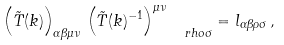<formula> <loc_0><loc_0><loc_500><loc_500>\left ( \tilde { T } ( k ) \right ) _ { \alpha \beta \mu \nu } \, \left ( \tilde { T } ( k ) ^ { - 1 } \right ) ^ { \mu \nu } _ { \quad r h o \sigma } = l _ { \alpha \beta \rho \sigma } \, ,</formula> 